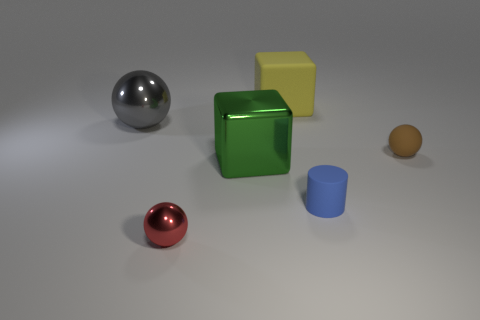How big is the red metallic sphere?
Offer a very short reply. Small. How big is the sphere that is right of the big block behind the gray thing that is left of the red metal thing?
Your answer should be very brief. Small. Are there any small brown spheres that have the same material as the yellow block?
Make the answer very short. Yes. The gray object is what shape?
Provide a short and direct response. Sphere. What color is the large cube that is made of the same material as the large sphere?
Your answer should be compact. Green. How many yellow things are small matte balls or tiny rubber things?
Your answer should be very brief. 0. Are there more cyan metal objects than tiny blue cylinders?
Your response must be concise. No. What number of objects are small balls to the right of the big yellow matte object or rubber objects on the right side of the small blue matte cylinder?
Provide a short and direct response. 1. There is a metallic sphere that is the same size as the blue object; what color is it?
Your answer should be very brief. Red. Does the blue cylinder have the same material as the large yellow block?
Make the answer very short. Yes. 